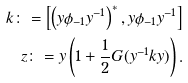Convert formula to latex. <formula><loc_0><loc_0><loc_500><loc_500>k \colon = \left [ \left ( y \phi _ { - 1 } y ^ { - 1 } \right ) ^ { * } , y \phi _ { - 1 } y ^ { - 1 } \right ] \\ z \colon = y \left ( 1 + \frac { 1 } { 2 } G ( y ^ { - 1 } k y ) \right ) .</formula> 